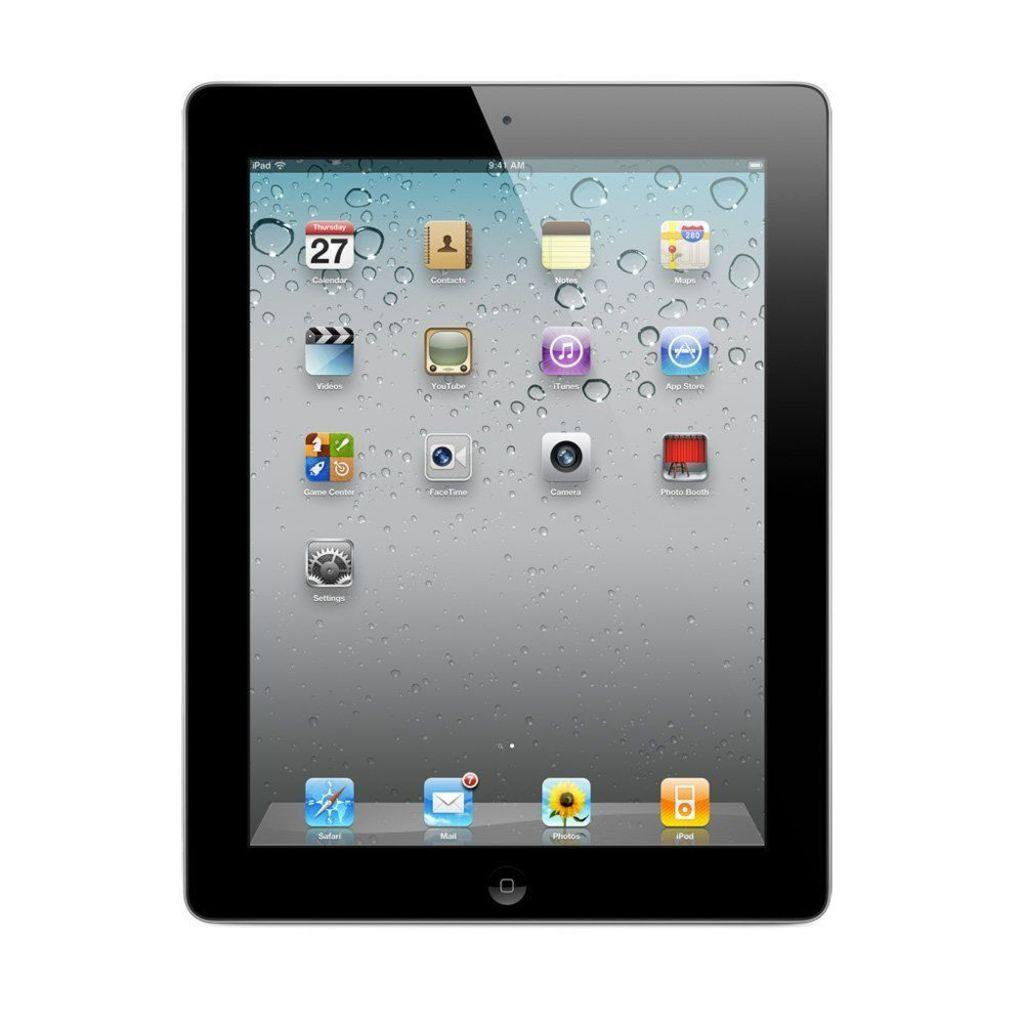What electronic device is visible in the image? There is an iPad in the image. What feature of the iPad is visible in the image? The iPad has a display screen. What type of science experiment is being conducted on the iPad in the image? There is no science experiment visible in the image; it only shows an iPad with a display screen. How many rabbits are hopping around the iPad in the image? There are no rabbits present in the image; it only shows an iPad with a display screen. 